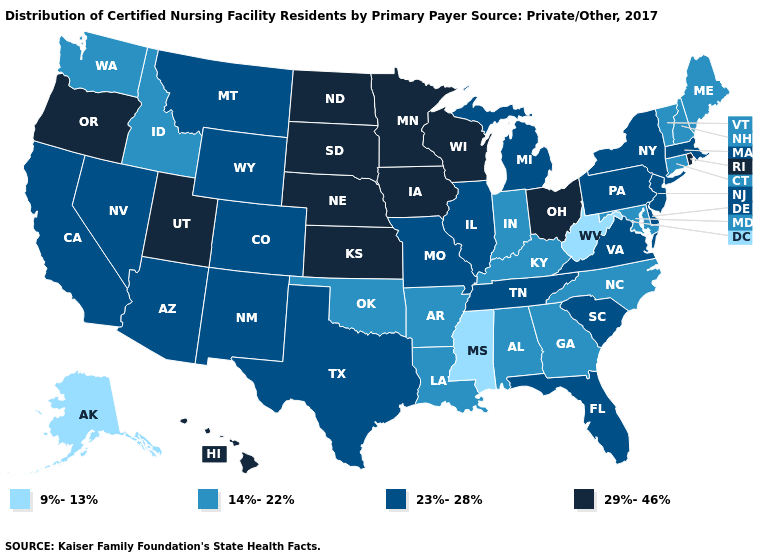Does New Jersey have the highest value in the Northeast?
Be succinct. No. Does Connecticut have a lower value than Arizona?
Quick response, please. Yes. Name the states that have a value in the range 9%-13%?
Keep it brief. Alaska, Mississippi, West Virginia. What is the lowest value in states that border Arizona?
Give a very brief answer. 23%-28%. What is the value of Washington?
Quick response, please. 14%-22%. What is the value of Colorado?
Be succinct. 23%-28%. Which states hav the highest value in the Northeast?
Short answer required. Rhode Island. Does Maine have the highest value in the USA?
Short answer required. No. Does Florida have the highest value in the USA?
Quick response, please. No. Name the states that have a value in the range 14%-22%?
Short answer required. Alabama, Arkansas, Connecticut, Georgia, Idaho, Indiana, Kentucky, Louisiana, Maine, Maryland, New Hampshire, North Carolina, Oklahoma, Vermont, Washington. Among the states that border Connecticut , does Massachusetts have the highest value?
Short answer required. No. What is the lowest value in states that border Alabama?
Keep it brief. 9%-13%. Among the states that border Arkansas , which have the highest value?
Answer briefly. Missouri, Tennessee, Texas. What is the lowest value in the Northeast?
Keep it brief. 14%-22%. What is the value of Connecticut?
Short answer required. 14%-22%. 